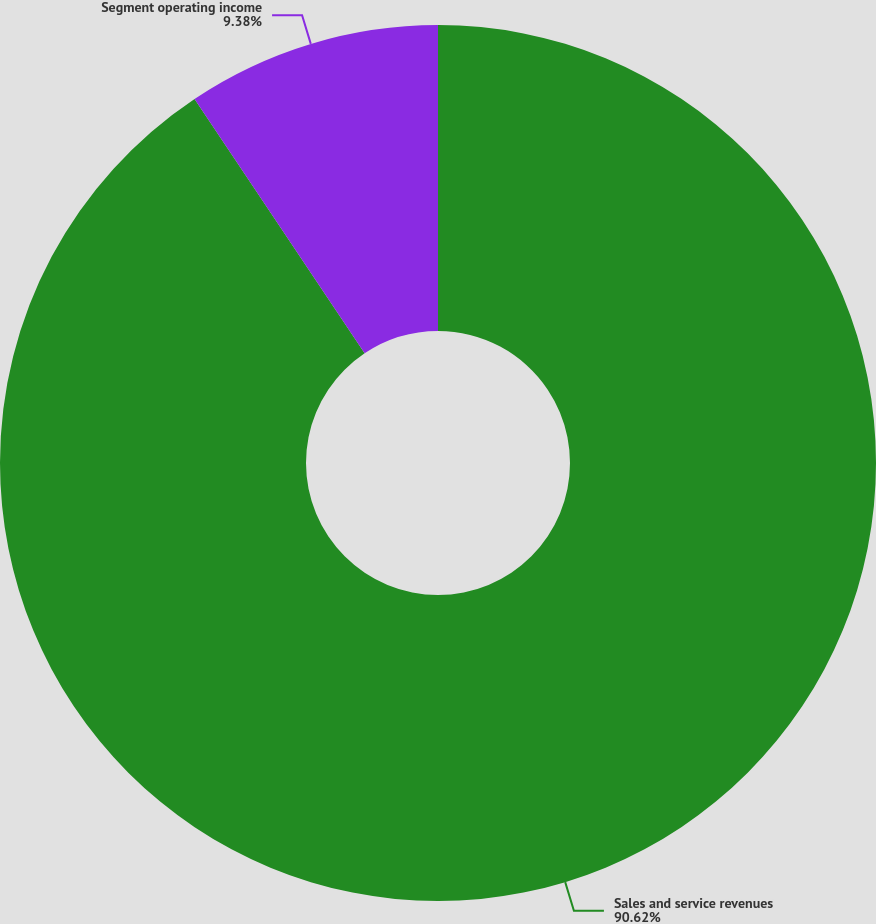Convert chart to OTSL. <chart><loc_0><loc_0><loc_500><loc_500><pie_chart><fcel>Sales and service revenues<fcel>Segment operating income<nl><fcel>90.62%<fcel>9.38%<nl></chart> 